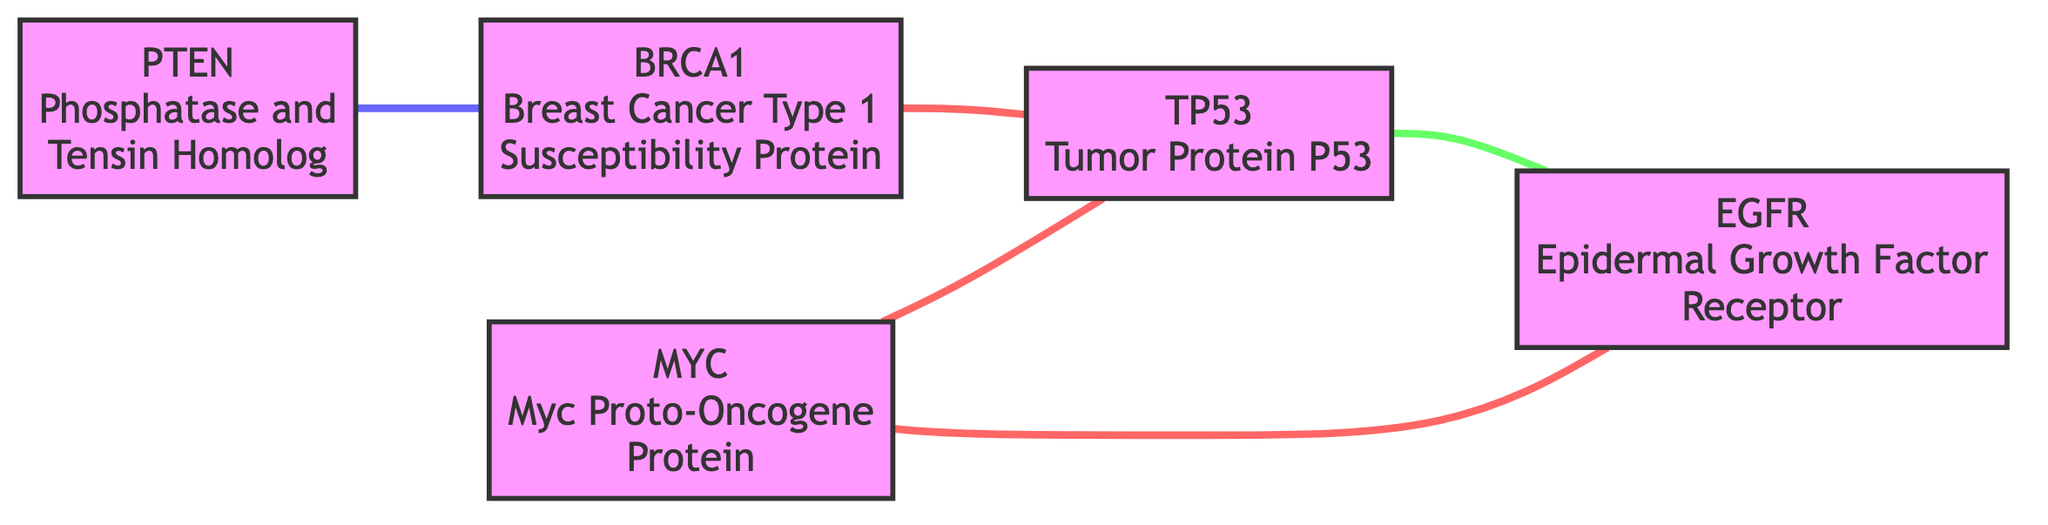What type of interaction exists between BRCA1 and TP53? The diagram indicates that the interaction type connecting BRCA1 and TP53 is labeled as "co-expression," which can be identified by the link between these two nodes and its respective color/style in the visual representation.
Answer: co-expression How many total genes are represented in this diagram? By counting the distinct gene nodes present in the diagram—BRCA1, TP53, EGFR, MYC, and PTEN—there are a total of five genes listed.
Answer: 5 Which gene has an inhibitory relation, and with which gene does it interact? The diagram shows that PTEN has an "inhibitory" interaction with BRCA1, identified by the colored link style that corresponds to inhibitory relations. Thus, PTEN interacts with BRCA1 in this context.
Answer: PTEN, BRCA1 How many total interactions are shown in the graph? To determine the total number of interactions, you can count the number of links connecting the gene nodes in the diagram. There are five distinct interactions displayed, linking the various genes.
Answer: 5 Which gene interacts with both MYC and TP53, and what type of interaction connects them? In the diagram, MYC interacts with TP53 through "co-expression," and this is indicated by the line connecting them along with the respective color/style that denotes this interaction type.
Answer: MYC, co-expression Is there a regulatory interaction involving EGFR? If so, with which gene? The diagram depicts a regulatory interaction where TP53 regulates EGFR, shown by the specific colored line linking these two nodes. This identifies TP53 as the gene involved in the regulatory interaction with EGFR.
Answer: TP53 What is the total number of co-expression interactions present in the graph? By analyzing the connections in the diagram, the co-expression interactions are found between BRCA1 and TP53, MYC and EGFR, and MYC and TP53. Thus, there are three distinct co-expression interactions represented.
Answer: 3 Which gene is not involved in any regulatory interaction depicted in the diagram? By reviewing the interactions, it can be noted that MYC does not participate in any regulatory interactions, focusing on the connections directly from the diagram views.
Answer: MYC 